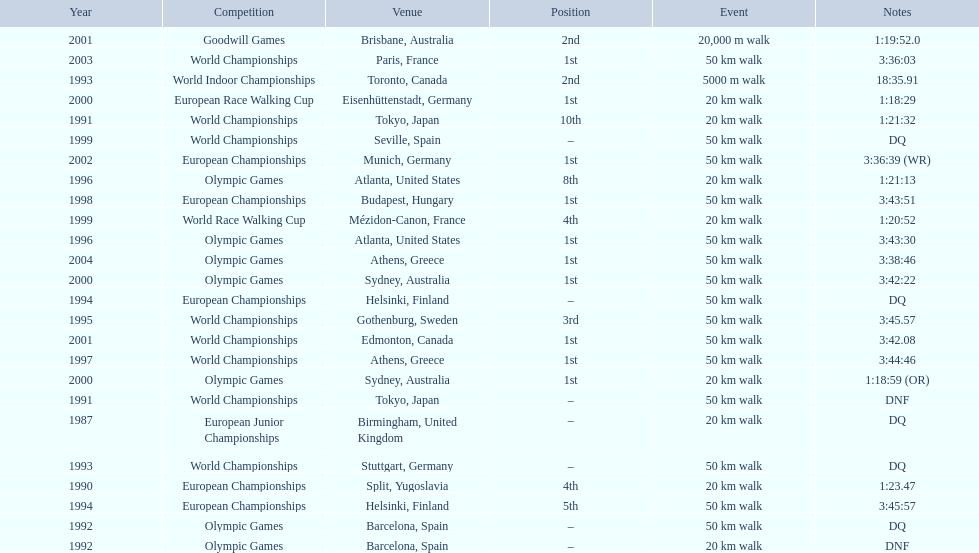What are the notes DQ, 1:23.47, 1:21:32, DNF, DNF, DQ, 18:35.91, DQ, DQ, 3:45:57, 3:45.57, 1:21:13, 3:43:30, 3:44:46, 3:43:51, 1:20:52, DQ, 1:18:29, 1:18:59 (OR), 3:42:22, 3:42.08, 1:19:52.0, 3:36:39 (WR), 3:36:03, 3:38:46. What time does the notes for 2004 show 3:38:46. 